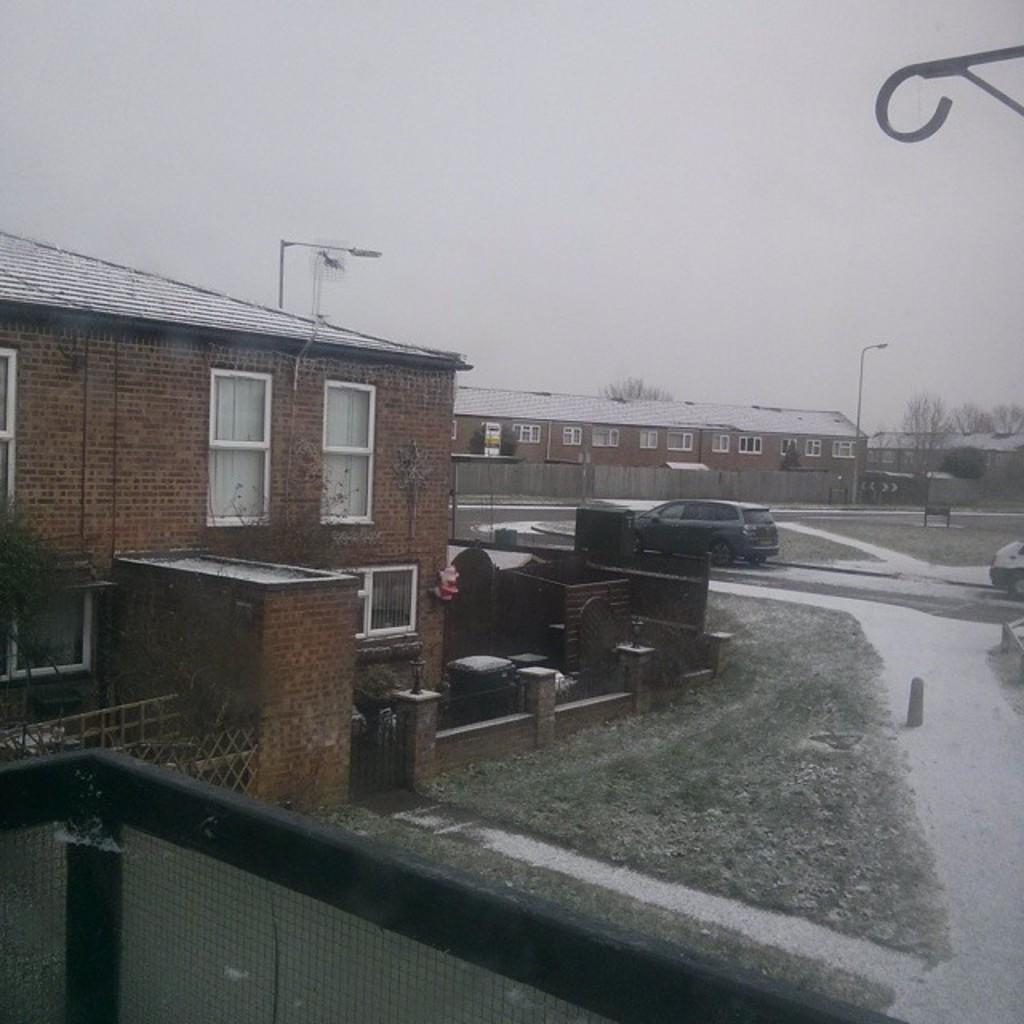Could you give a brief overview of what you see in this image? On the left side, there is building, which is having glass windows and roof, near some objects and wall, which is near grass on the ground and the road, on which, there are vehicles. In the background, there are buildings and there is sky. 